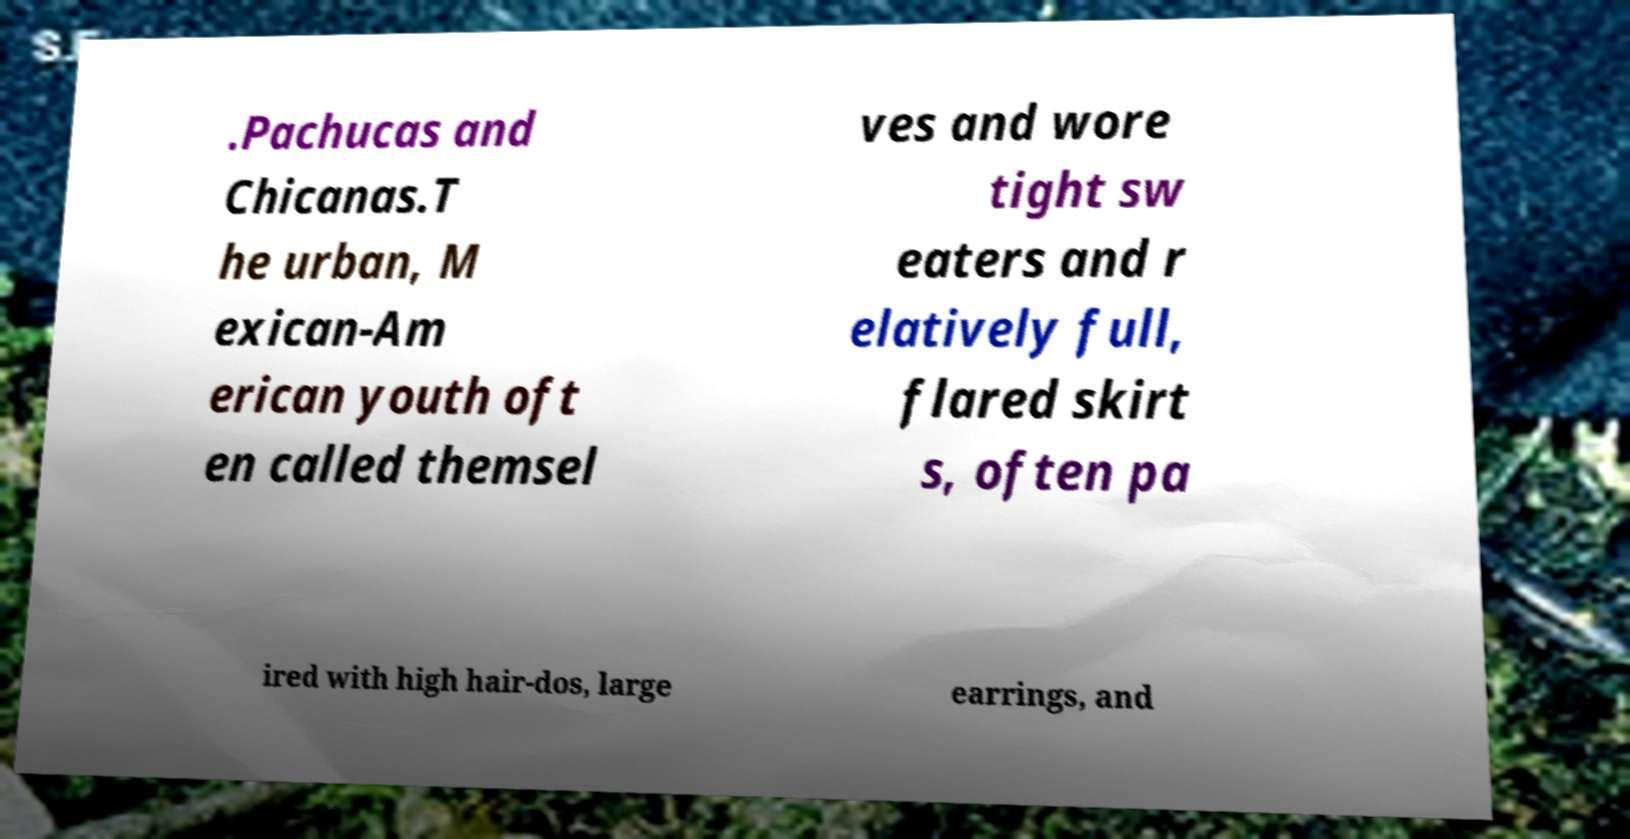What messages or text are displayed in this image? I need them in a readable, typed format. .Pachucas and Chicanas.T he urban, M exican-Am erican youth oft en called themsel ves and wore tight sw eaters and r elatively full, flared skirt s, often pa ired with high hair-dos, large earrings, and 